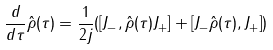<formula> <loc_0><loc_0><loc_500><loc_500>\frac { d } { d \tau } \hat { \rho } ( \tau ) = \frac { 1 } { 2 j } ( [ J _ { - } , \hat { \rho } ( \tau ) J _ { + } ] + [ J _ { - } \hat { \rho } ( \tau ) , J _ { + } ] )</formula> 